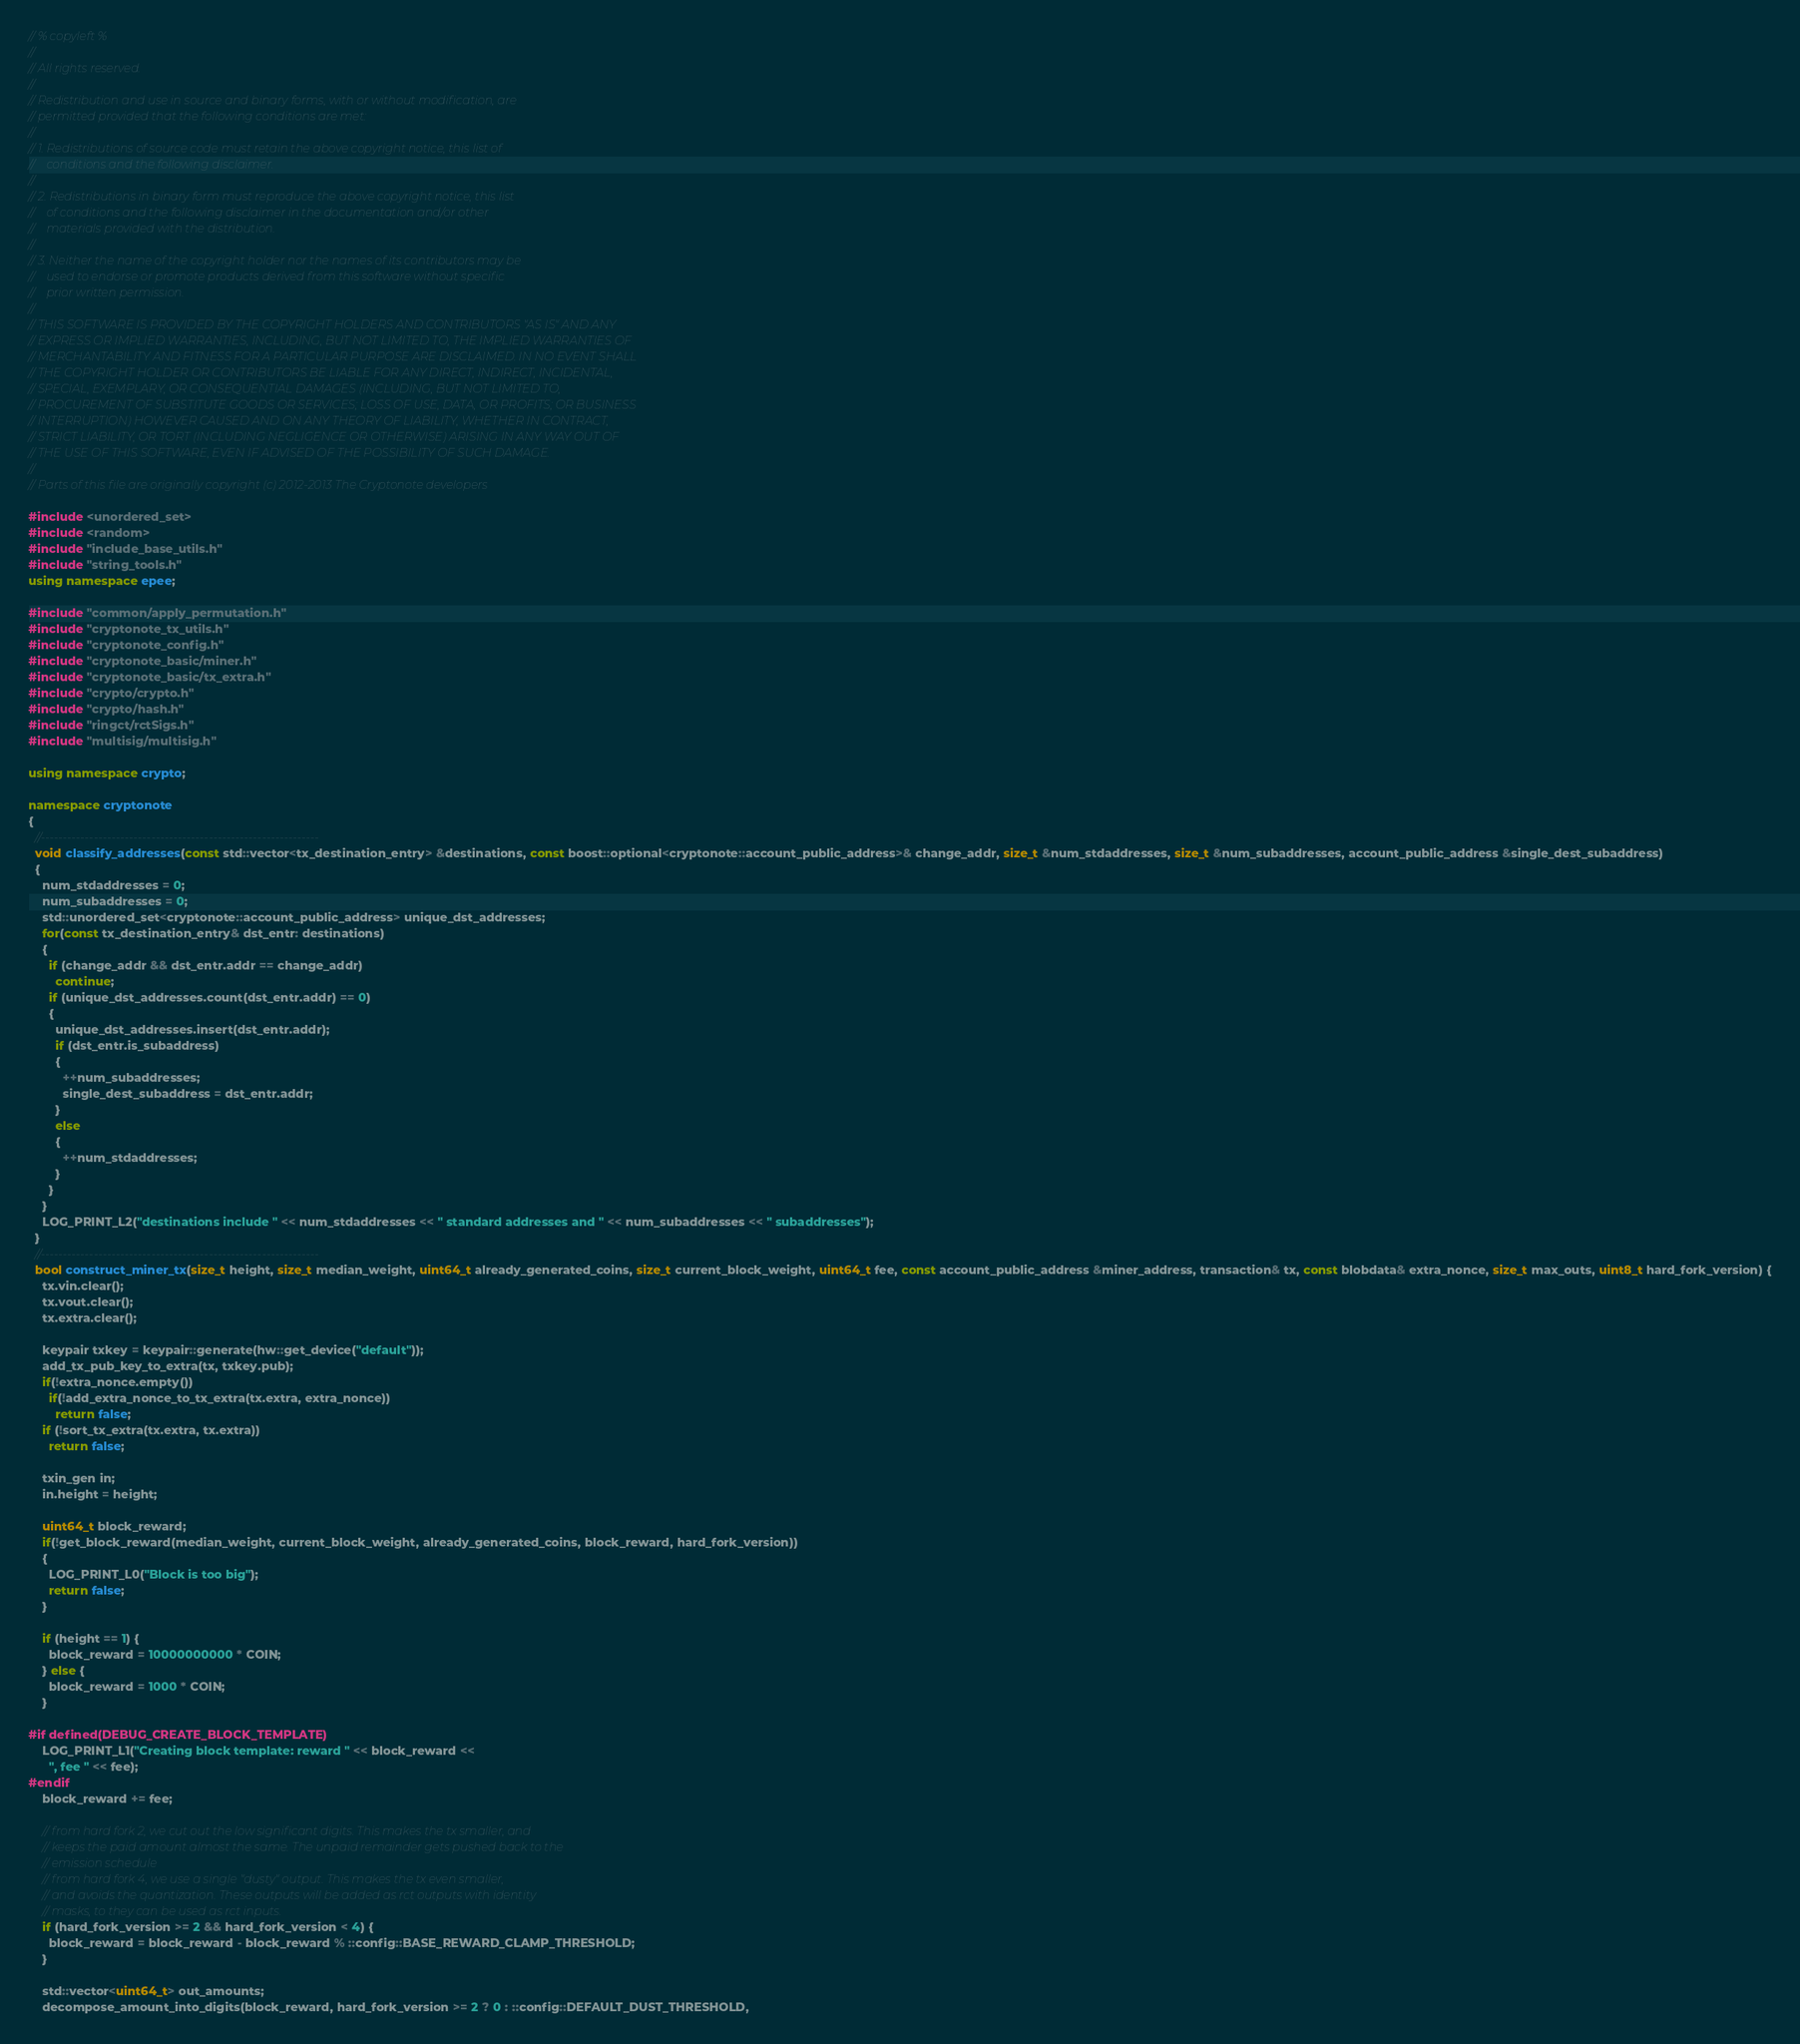Convert code to text. <code><loc_0><loc_0><loc_500><loc_500><_C++_>// % copyleft %
// 
// All rights reserved.
// 
// Redistribution and use in source and binary forms, with or without modification, are
// permitted provided that the following conditions are met:
// 
// 1. Redistributions of source code must retain the above copyright notice, this list of
//    conditions and the following disclaimer.
// 
// 2. Redistributions in binary form must reproduce the above copyright notice, this list
//    of conditions and the following disclaimer in the documentation and/or other
//    materials provided with the distribution.
// 
// 3. Neither the name of the copyright holder nor the names of its contributors may be
//    used to endorse or promote products derived from this software without specific
//    prior written permission.
// 
// THIS SOFTWARE IS PROVIDED BY THE COPYRIGHT HOLDERS AND CONTRIBUTORS "AS IS" AND ANY
// EXPRESS OR IMPLIED WARRANTIES, INCLUDING, BUT NOT LIMITED TO, THE IMPLIED WARRANTIES OF
// MERCHANTABILITY AND FITNESS FOR A PARTICULAR PURPOSE ARE DISCLAIMED. IN NO EVENT SHALL
// THE COPYRIGHT HOLDER OR CONTRIBUTORS BE LIABLE FOR ANY DIRECT, INDIRECT, INCIDENTAL,
// SPECIAL, EXEMPLARY, OR CONSEQUENTIAL DAMAGES (INCLUDING, BUT NOT LIMITED TO,
// PROCUREMENT OF SUBSTITUTE GOODS OR SERVICES; LOSS OF USE, DATA, OR PROFITS; OR BUSINESS
// INTERRUPTION) HOWEVER CAUSED AND ON ANY THEORY OF LIABILITY, WHETHER IN CONTRACT,
// STRICT LIABILITY, OR TORT (INCLUDING NEGLIGENCE OR OTHERWISE) ARISING IN ANY WAY OUT OF
// THE USE OF THIS SOFTWARE, EVEN IF ADVISED OF THE POSSIBILITY OF SUCH DAMAGE.
// 
// Parts of this file are originally copyright (c) 2012-2013 The Cryptonote developers

#include <unordered_set>
#include <random>
#include "include_base_utils.h"
#include "string_tools.h"
using namespace epee;

#include "common/apply_permutation.h"
#include "cryptonote_tx_utils.h"
#include "cryptonote_config.h"
#include "cryptonote_basic/miner.h"
#include "cryptonote_basic/tx_extra.h"
#include "crypto/crypto.h"
#include "crypto/hash.h"
#include "ringct/rctSigs.h"
#include "multisig/multisig.h"

using namespace crypto;

namespace cryptonote
{
  //---------------------------------------------------------------
  void classify_addresses(const std::vector<tx_destination_entry> &destinations, const boost::optional<cryptonote::account_public_address>& change_addr, size_t &num_stdaddresses, size_t &num_subaddresses, account_public_address &single_dest_subaddress)
  {
    num_stdaddresses = 0;
    num_subaddresses = 0;
    std::unordered_set<cryptonote::account_public_address> unique_dst_addresses;
    for(const tx_destination_entry& dst_entr: destinations)
    {
      if (change_addr && dst_entr.addr == change_addr)
        continue;
      if (unique_dst_addresses.count(dst_entr.addr) == 0)
      {
        unique_dst_addresses.insert(dst_entr.addr);
        if (dst_entr.is_subaddress)
        {
          ++num_subaddresses;
          single_dest_subaddress = dst_entr.addr;
        }
        else
        {
          ++num_stdaddresses;
        }
      }
    }
    LOG_PRINT_L2("destinations include " << num_stdaddresses << " standard addresses and " << num_subaddresses << " subaddresses");
  }
  //---------------------------------------------------------------
  bool construct_miner_tx(size_t height, size_t median_weight, uint64_t already_generated_coins, size_t current_block_weight, uint64_t fee, const account_public_address &miner_address, transaction& tx, const blobdata& extra_nonce, size_t max_outs, uint8_t hard_fork_version) {
    tx.vin.clear();
    tx.vout.clear();
    tx.extra.clear();

    keypair txkey = keypair::generate(hw::get_device("default"));
    add_tx_pub_key_to_extra(tx, txkey.pub);
    if(!extra_nonce.empty())
      if(!add_extra_nonce_to_tx_extra(tx.extra, extra_nonce))
        return false;
    if (!sort_tx_extra(tx.extra, tx.extra))
      return false;

    txin_gen in;
    in.height = height;

    uint64_t block_reward;
    if(!get_block_reward(median_weight, current_block_weight, already_generated_coins, block_reward, hard_fork_version))
    {
      LOG_PRINT_L0("Block is too big");
      return false;
    }

    if (height == 1) {
      block_reward = 10000000000 * COIN;
    } else {
      block_reward = 1000 * COIN;
    }

#if defined(DEBUG_CREATE_BLOCK_TEMPLATE)
    LOG_PRINT_L1("Creating block template: reward " << block_reward <<
      ", fee " << fee);
#endif
    block_reward += fee;

    // from hard fork 2, we cut out the low significant digits. This makes the tx smaller, and
    // keeps the paid amount almost the same. The unpaid remainder gets pushed back to the
    // emission schedule
    // from hard fork 4, we use a single "dusty" output. This makes the tx even smaller,
    // and avoids the quantization. These outputs will be added as rct outputs with identity
    // masks, to they can be used as rct inputs.
    if (hard_fork_version >= 2 && hard_fork_version < 4) {
      block_reward = block_reward - block_reward % ::config::BASE_REWARD_CLAMP_THRESHOLD;
    }

    std::vector<uint64_t> out_amounts;
    decompose_amount_into_digits(block_reward, hard_fork_version >= 2 ? 0 : ::config::DEFAULT_DUST_THRESHOLD,</code> 